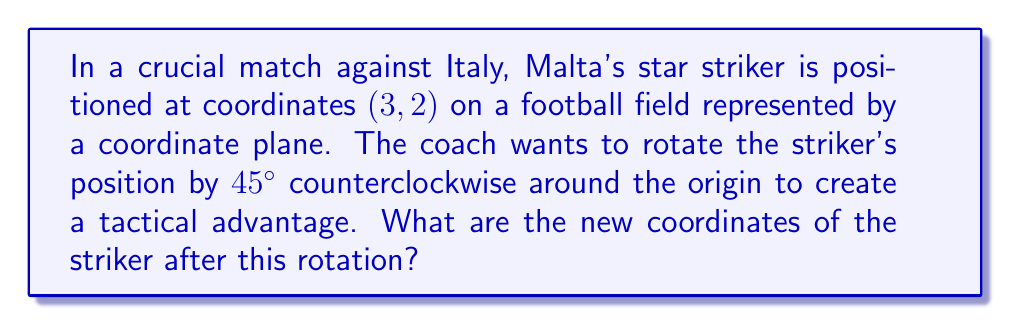Can you solve this math problem? To solve this problem, we'll use the rotation matrix for a 45° counterclockwise rotation. The rotation matrix for an angle $\theta$ is:

$$
R(\theta) = \begin{pmatrix}
\cos\theta & -\sin\theta \\
\sin\theta & \cos\theta
\end{pmatrix}
$$

For a 45° rotation, we know that $\cos 45° = \sin 45° = \frac{1}{\sqrt{2}}$. So our rotation matrix becomes:

$$
R(45°) = \begin{pmatrix}
\frac{1}{\sqrt{2}} & -\frac{1}{\sqrt{2}} \\
\frac{1}{\sqrt{2}} & \frac{1}{\sqrt{2}}
\end{pmatrix}
$$

To find the new coordinates, we multiply this matrix by the original position vector:

$$
\begin{pmatrix}
\frac{1}{\sqrt{2}} & -\frac{1}{\sqrt{2}} \\
\frac{1}{\sqrt{2}} & \frac{1}{\sqrt{2}}
\end{pmatrix}
\begin{pmatrix}
3 \\
2
\end{pmatrix}
=
\begin{pmatrix}
\frac{1}{\sqrt{2}}(3) - \frac{1}{\sqrt{2}}(2) \\
\frac{1}{\sqrt{2}}(3) + \frac{1}{\sqrt{2}}(2)
\end{pmatrix}
$$

Simplifying:

$$
\begin{pmatrix}
\frac{3-2}{\sqrt{2}} \\
\frac{3+2}{\sqrt{2}}
\end{pmatrix}
=
\begin{pmatrix}
\frac{1}{\sqrt{2}} \\
\frac{5}{\sqrt{2}}
\end{pmatrix}
$$

To simplify further, we can rationalize the denominator:

$$
\begin{pmatrix}
\frac{1}{\sqrt{2}} \cdot \frac{\sqrt{2}}{\sqrt{2}} \\
\frac{5}{\sqrt{2}} \cdot \frac{\sqrt{2}}{\sqrt{2}}
\end{pmatrix}
=
\begin{pmatrix}
\frac{\sqrt{2}}{2} \\
\frac{5\sqrt{2}}{2}
\end{pmatrix}
$$
Answer: The new coordinates of the striker after the 45° counterclockwise rotation are $(\frac{\sqrt{2}}{2}, \frac{5\sqrt{2}}{2})$. 